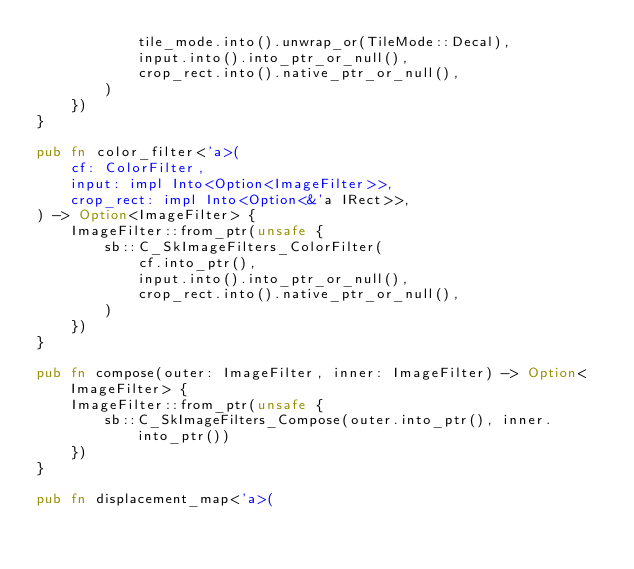Convert code to text. <code><loc_0><loc_0><loc_500><loc_500><_Rust_>            tile_mode.into().unwrap_or(TileMode::Decal),
            input.into().into_ptr_or_null(),
            crop_rect.into().native_ptr_or_null(),
        )
    })
}

pub fn color_filter<'a>(
    cf: ColorFilter,
    input: impl Into<Option<ImageFilter>>,
    crop_rect: impl Into<Option<&'a IRect>>,
) -> Option<ImageFilter> {
    ImageFilter::from_ptr(unsafe {
        sb::C_SkImageFilters_ColorFilter(
            cf.into_ptr(),
            input.into().into_ptr_or_null(),
            crop_rect.into().native_ptr_or_null(),
        )
    })
}

pub fn compose(outer: ImageFilter, inner: ImageFilter) -> Option<ImageFilter> {
    ImageFilter::from_ptr(unsafe {
        sb::C_SkImageFilters_Compose(outer.into_ptr(), inner.into_ptr())
    })
}

pub fn displacement_map<'a>(</code> 